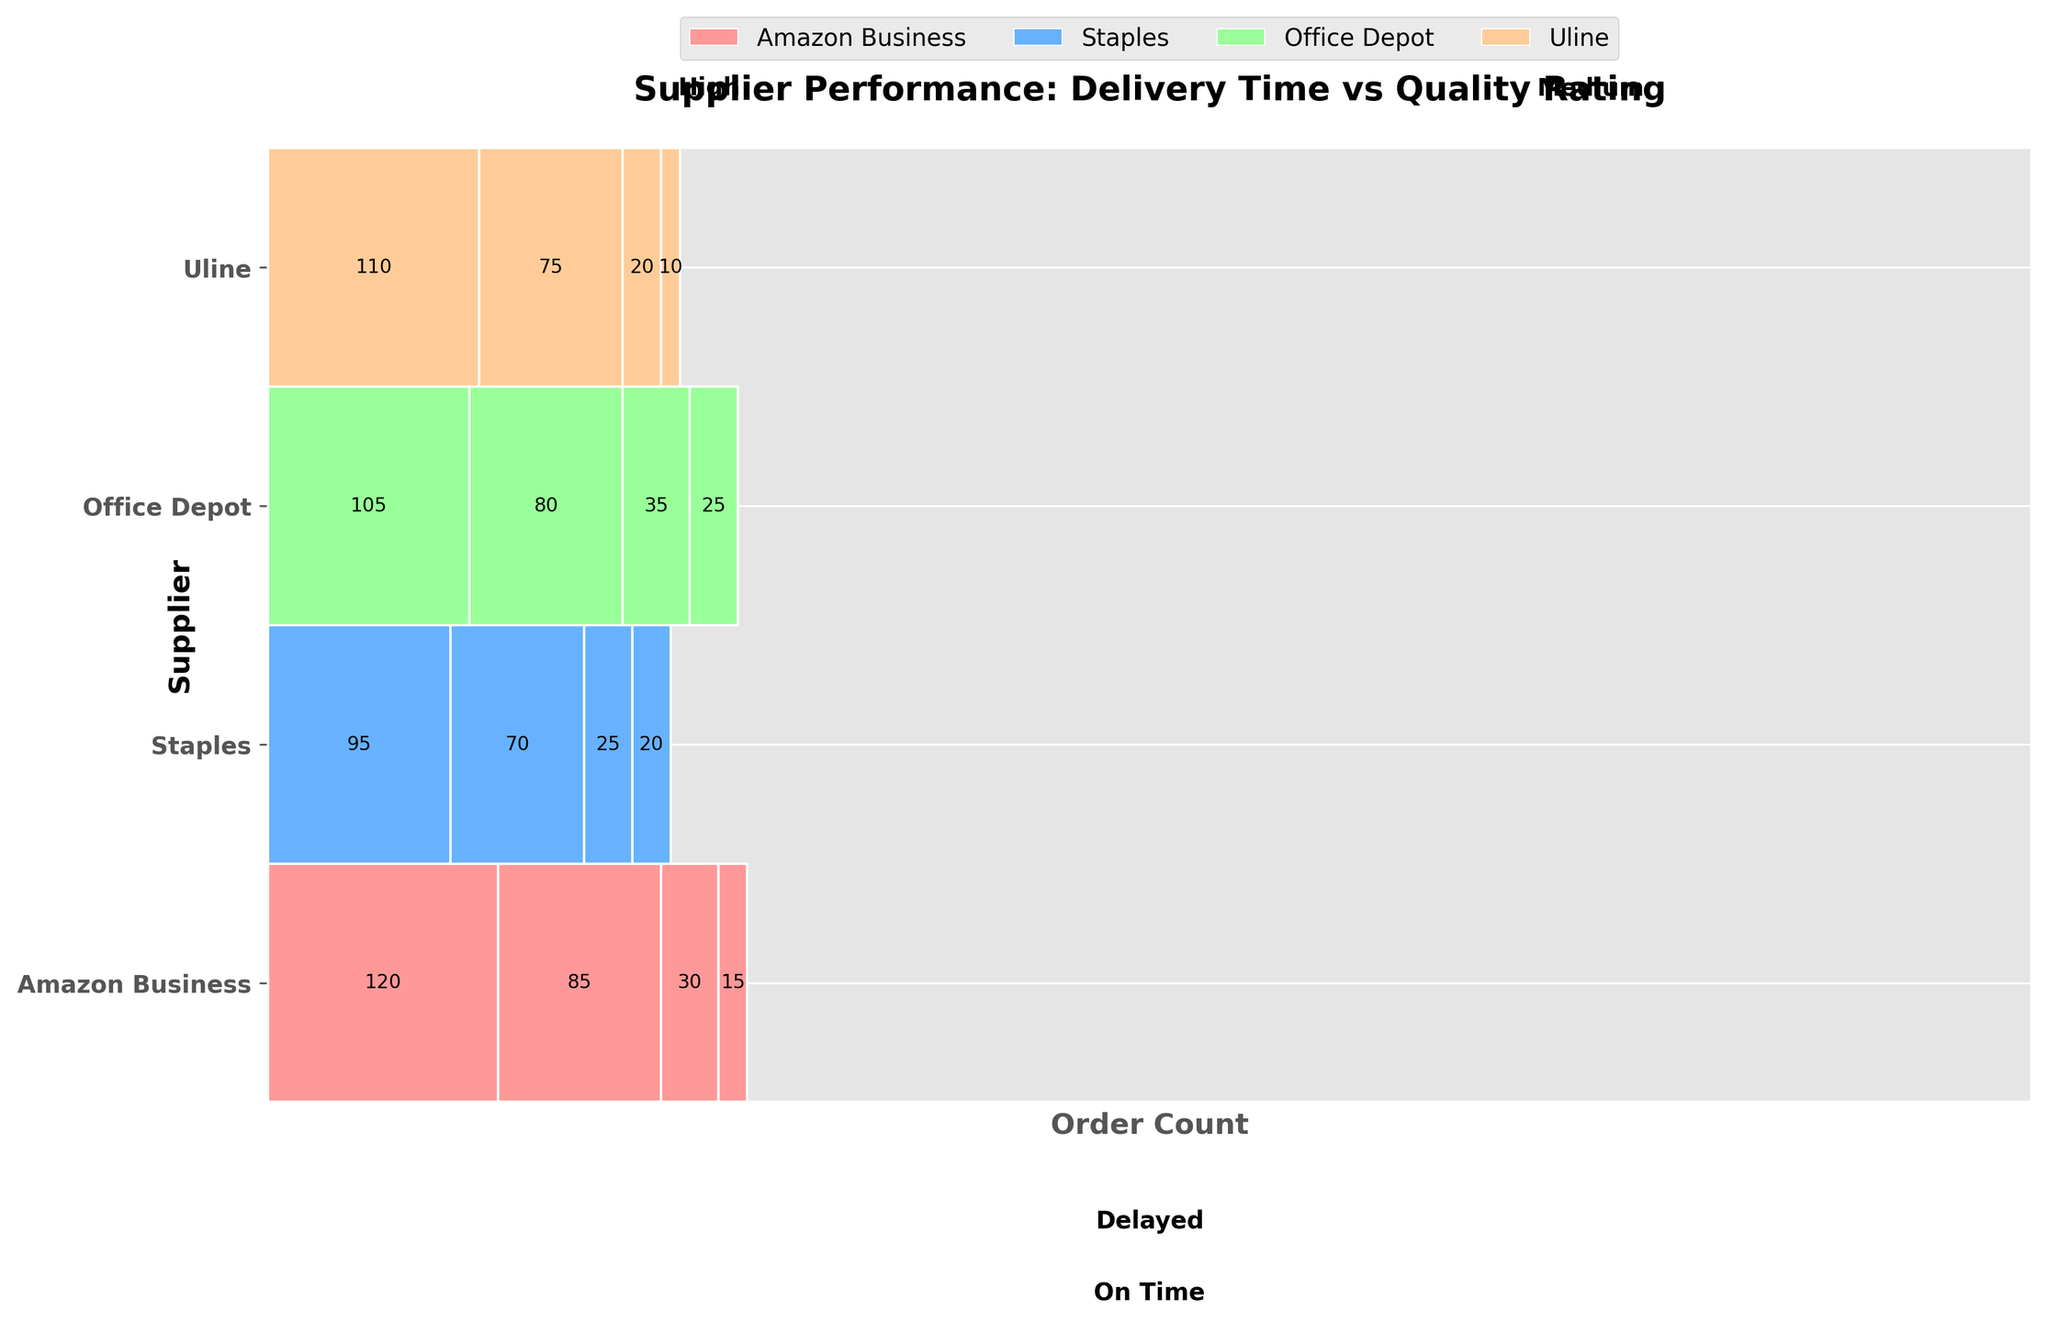What is the title of the mosaic plot? The title is typically placed at the top of the figure and describes what the plot represents. In this case, it is written explicitly in the code provided.
Answer: Supplier Performance: Delivery Time vs Quality Rating How many suppliers are evaluated in the plot? The plot has distinct horizontal bars for each supplier, which corresponds to the number of unique suppliers in the data. According to the code, these are listed as "Amazon Business," "Staples," "Office Depot," and "Uline."
Answer: 4 Which supplier has the highest number of 'On Time' and 'High' quality orders? By examining the segments of the mosaic plot for each supplier, we look for the segment with the largest width that corresponds to 'On Time' and 'High' quality orders. According to the data, "Amazon Business" has 120 such orders.
Answer: Amazon Business Comparing 'Amazon Business' and 'Staples,' which one has more delayed orders with medium quality ratings? We need to compare the widths of the segments in the mosaic plot that represent delayed delivery with medium quality rating for these two suppliers. "Amazon Business" has 15, and "Staples" has 20 such orders.
Answer: Staples What is the total number of orders with medium quality ratings across all suppliers? This requires summing up the order counts for medium quality ratings for both 'On Time' and 'Delayed' deliveries across all suppliers. Summing up the relevant segments: 85 + 15 (Amazon Business) + 70 + 20 (Staples) + 80 + 25 (Office Depot) + 75 + 10 (Uline).
Answer: 380 How does the performance of 'Office Depot' compare to 'Uline' in terms of delayed orders with high quality? We need to compare the widths of the segments for delayed delivery with high quality ratings. According to the data, "Office Depot" has 35 orders, while "Uline" has 20 in this category.
Answer: Office Depot What is the proportion of 'On Time' deliveries to total deliveries for 'Staples'? Calculate the proportion by summing up 'On Time' deliveries for 'Staples' (95 + 70) and dividing by the total deliveries (95 + 70 + 25 + 20).
Answer: 0.77 Which segment is the smallest in the mosaic plot? The smallest segment in a mosaic plot is the one with the smallest width. Based on the data, the "Delayed" and "Medium" orders for "Uline" are only 10.
Answer: Uline with Delayed and Medium quality rating For "Amazon Business," how do the number of 'On Time' and 'High' quality orders compare to 'On Time' and 'Medium' quality orders? By comparing the widths of the respective segments, we see that "Amazon Business" has 120 'On Time' and 'High' orders compared to 85 'On Time' and 'Medium' orders.
Answer: 120 vs 85 